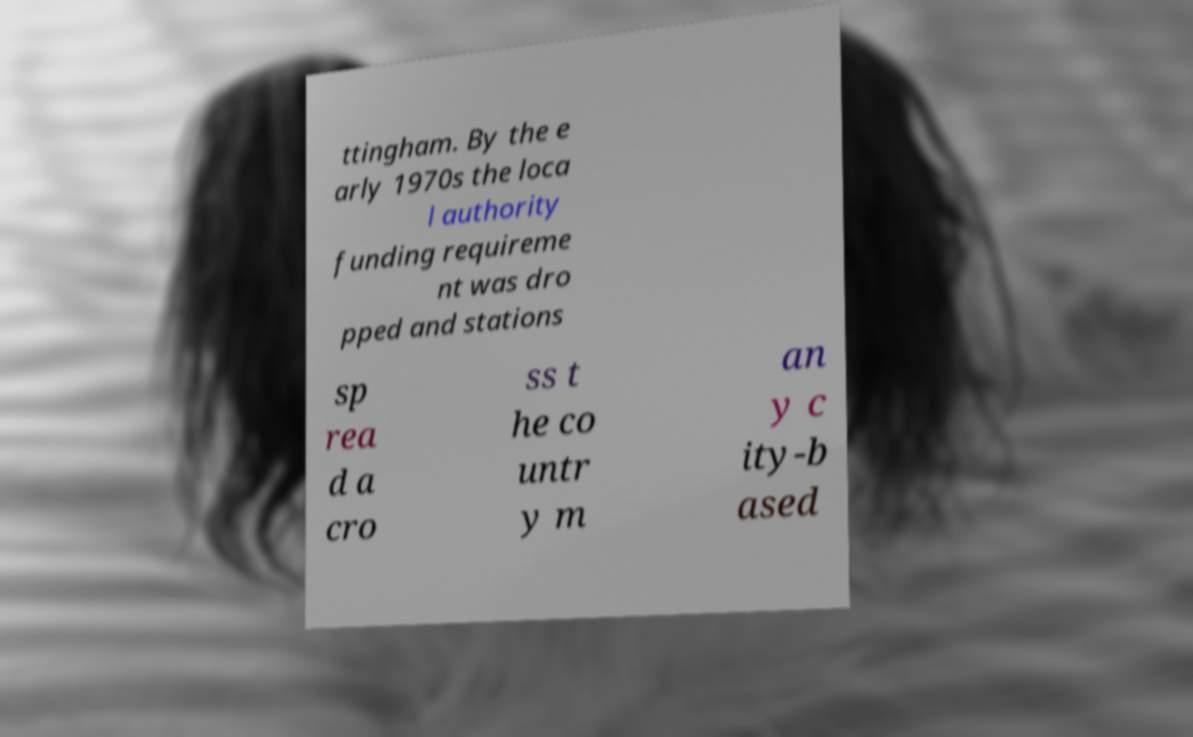Please identify and transcribe the text found in this image. ttingham. By the e arly 1970s the loca l authority funding requireme nt was dro pped and stations sp rea d a cro ss t he co untr y m an y c ity-b ased 